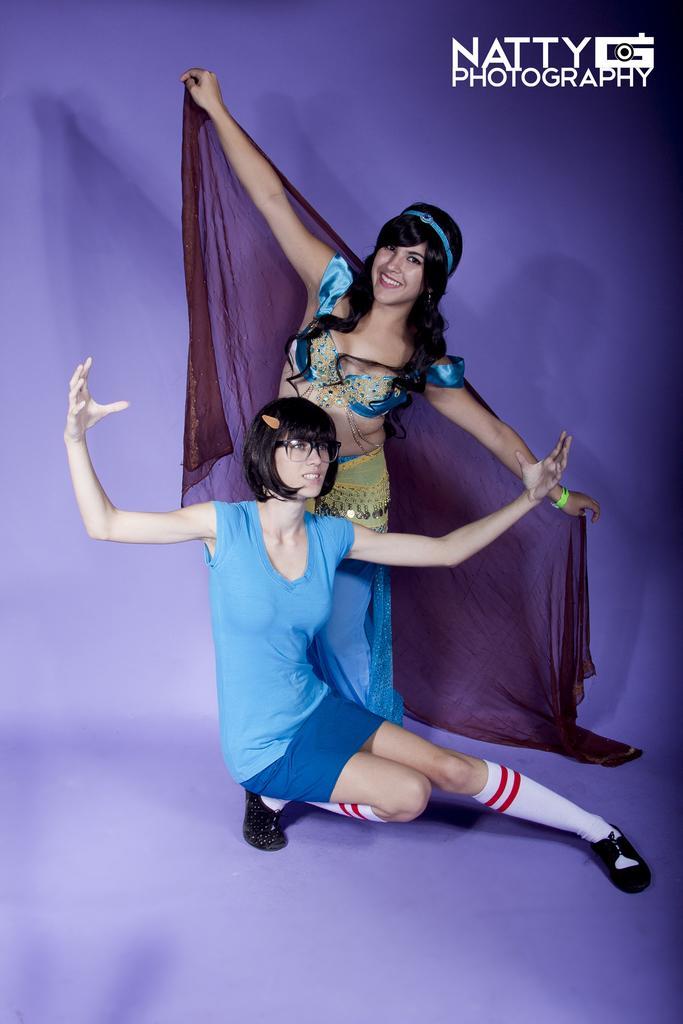In one or two sentences, can you explain what this image depicts? In this image there are two girls with dancing pose and water mark on it. 